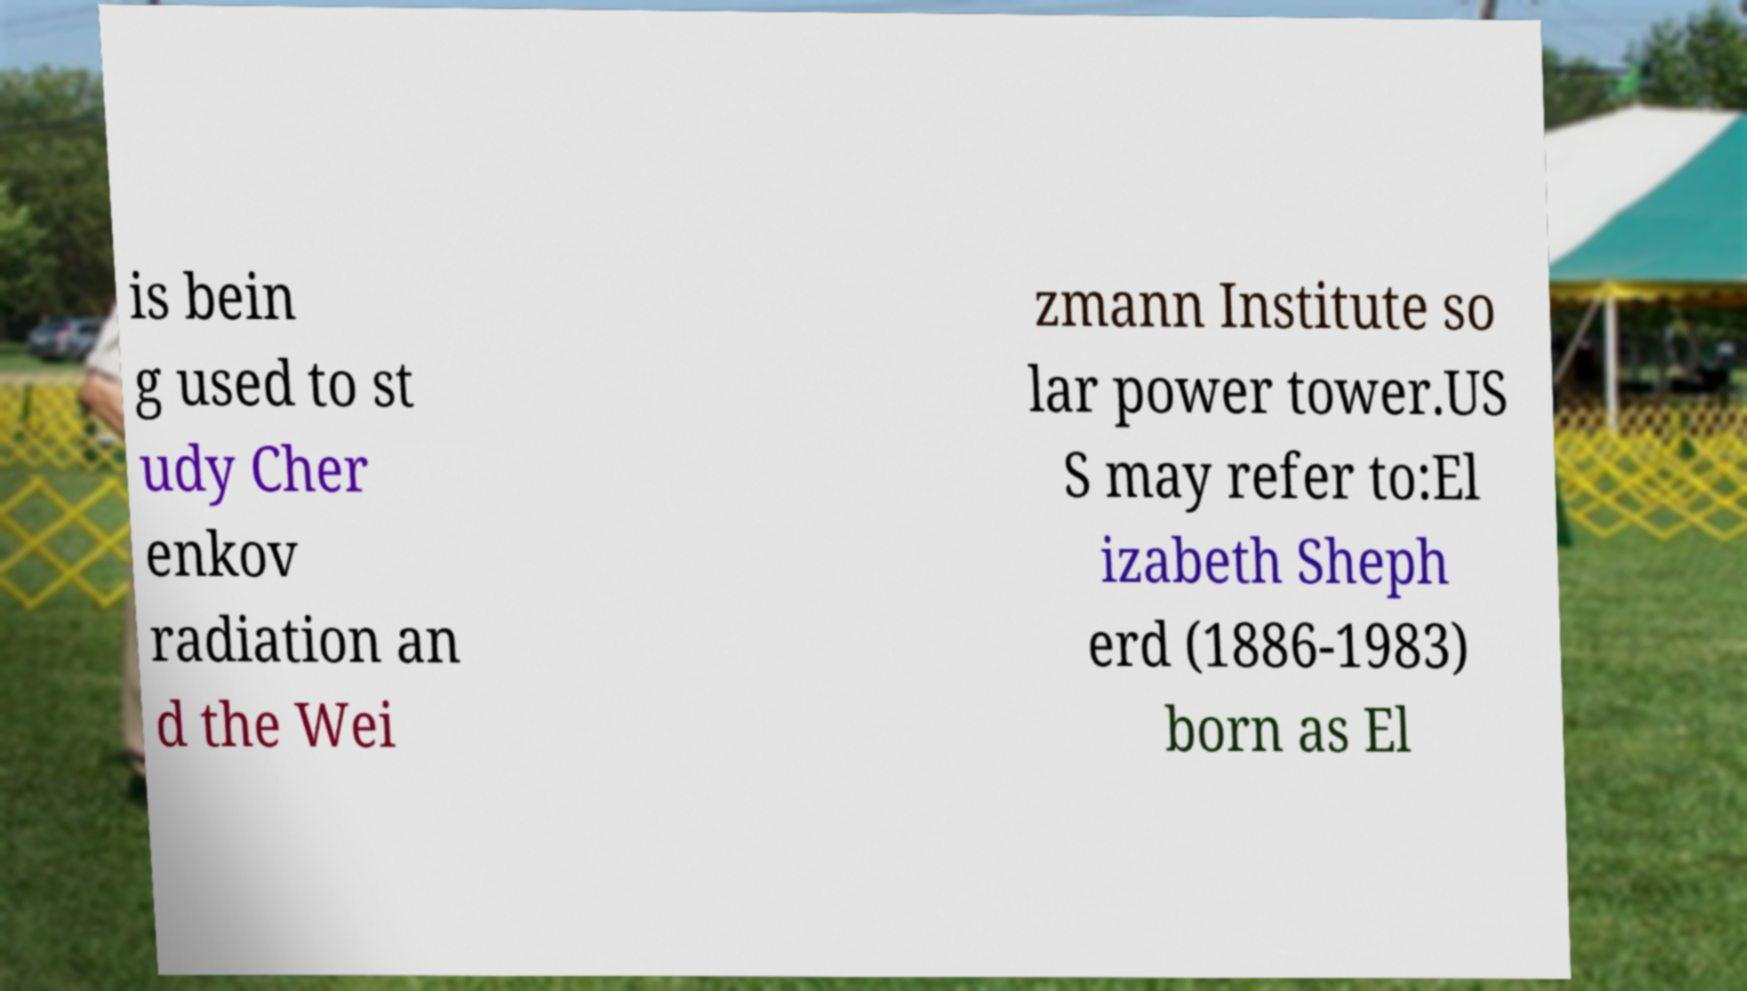Can you read and provide the text displayed in the image?This photo seems to have some interesting text. Can you extract and type it out for me? is bein g used to st udy Cher enkov radiation an d the Wei zmann Institute so lar power tower.US S may refer to:El izabeth Sheph erd (1886-1983) born as El 